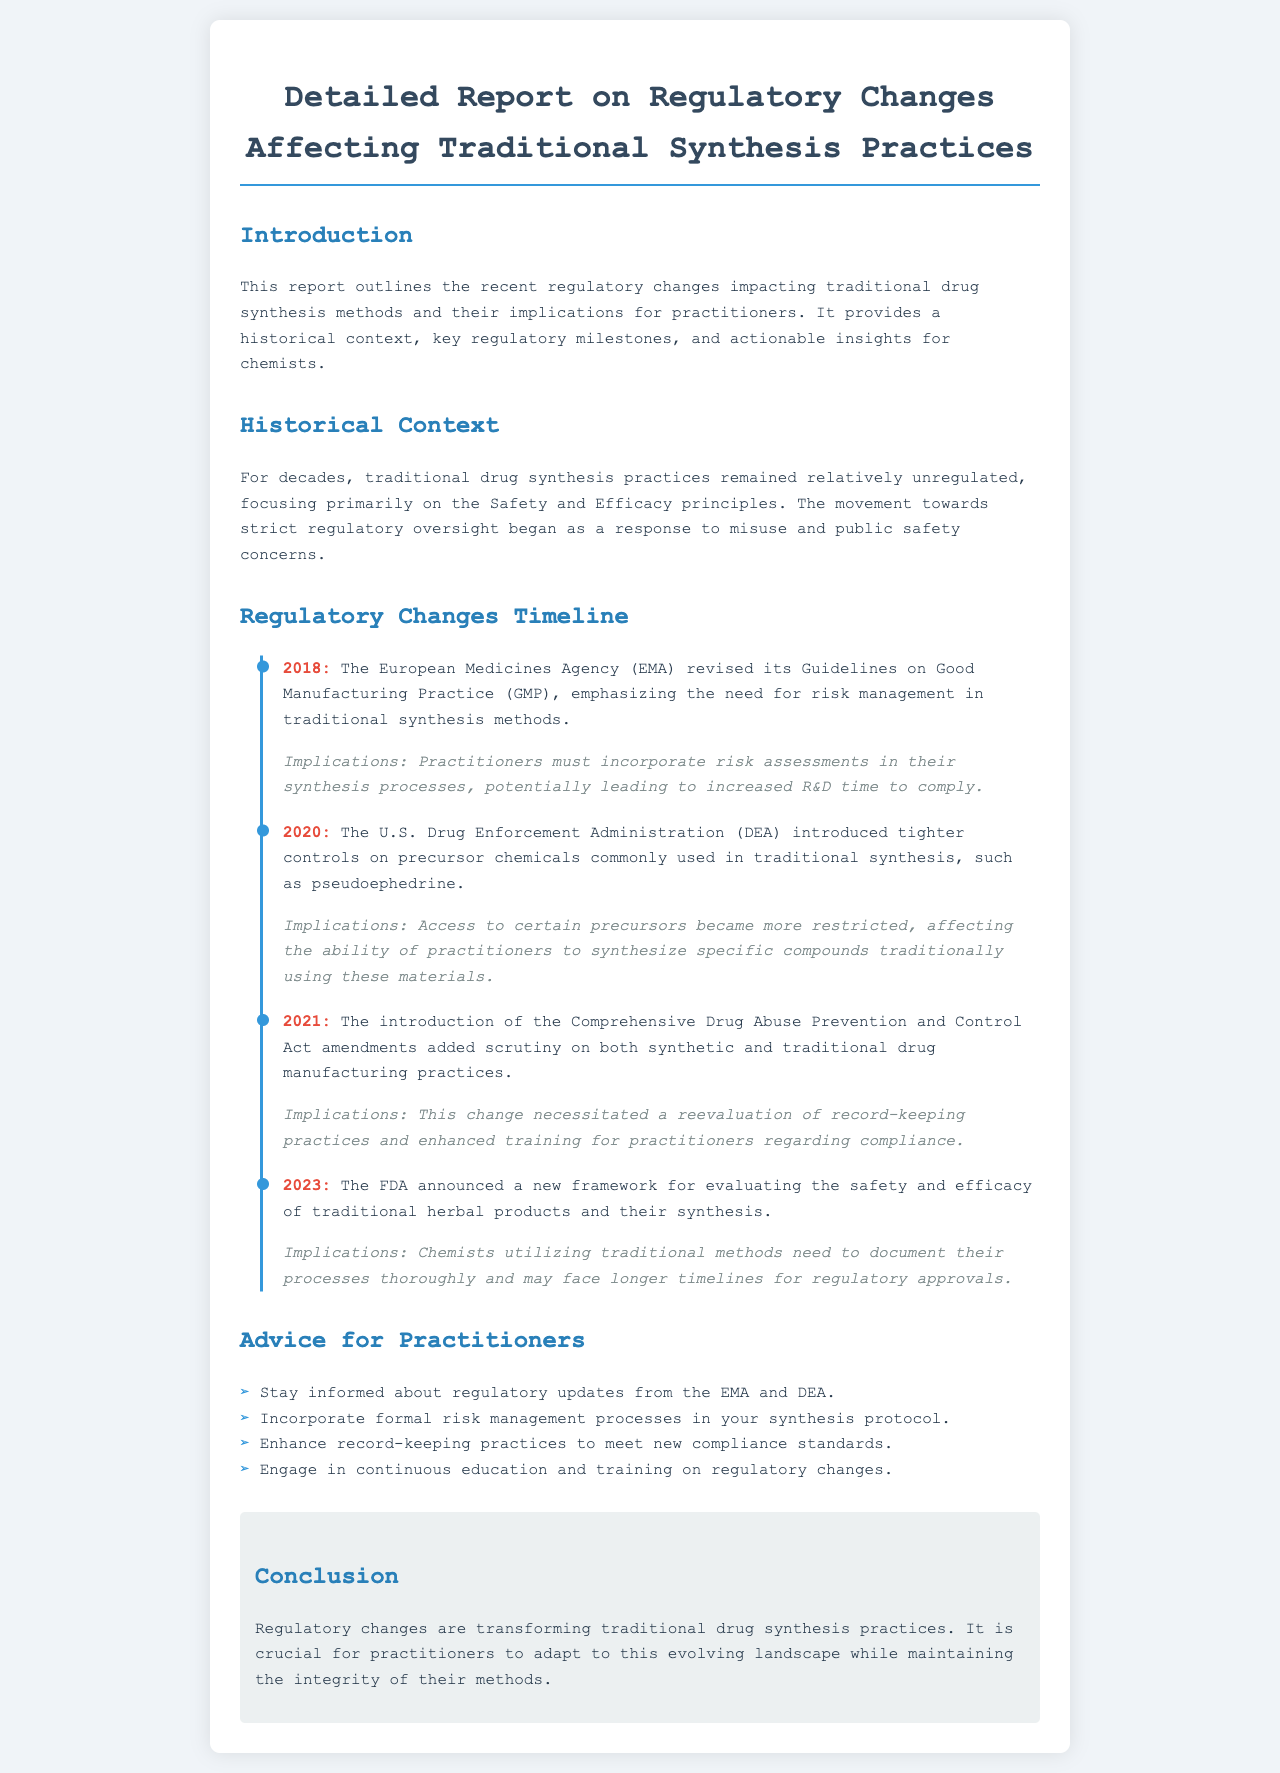What organization revised its GMP guidelines in 2018? The document states that the European Medicines Agency revised its Guidelines on Good Manufacturing Practice in 2018.
Answer: European Medicines Agency What year did the DEA introduce tighter controls on precursor chemicals? According to the timeline, tighter controls were introduced by the DEA in 2020.
Answer: 2020 What amendment added scrutiny on drug manufacturing practices in 2021? The Comprehensive Drug Abuse Prevention and Control Act amendments added scrutiny in 2021.
Answer: Comprehensive Drug Abuse Prevention and Control Act What is a key implication of the FDA's announcement in 2023? The document mentions that chemists need to document their processes thoroughly due to the FDA's announcement in 2023.
Answer: Document processes thoroughly What is one piece of advice for practitioners mentioned in the report? The document lists several pieces of advice, one being to stay informed about regulatory updates.
Answer: Stay informed about regulatory updates What color is used for the timeline in the document? The timeline is highlighted by a blue border, which is the color used in the design.
Answer: Blue What does the current regulatory landscape affect according to the conclusion? The conclusion emphasizes that practitioners need to adapt to the evolving regulatory landscape affecting their methods.
Answer: Methods What is the primary focus of the historical context section? The historical context primarily discusses the relative lack of regulation prior to recent changes.
Answer: Lack of regulation prior to changes 